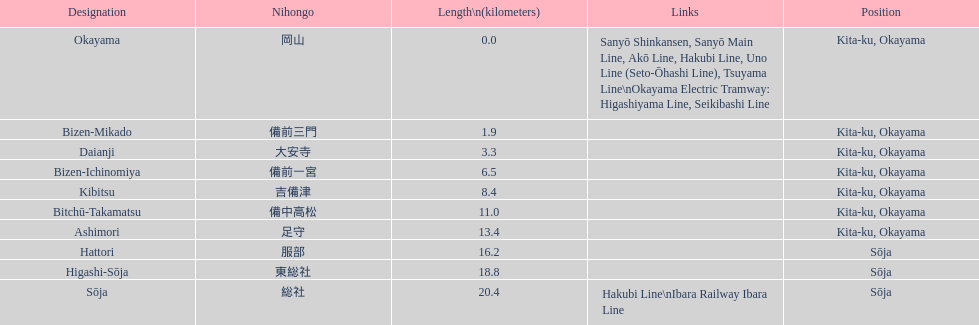Which has the most distance, hattori or kibitsu? Hattori. 